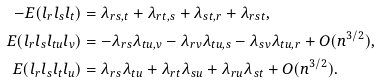Convert formula to latex. <formula><loc_0><loc_0><loc_500><loc_500>- E ( l _ { r } l _ { s } l _ { t } ) & = \lambda _ { r s , t } + \lambda _ { r t , s } + \lambda _ { s t , r } + \lambda _ { r s t } , \\ E ( l _ { r } l _ { s } l _ { t u } l _ { v } ) & = - \lambda _ { r s } \lambda _ { t u , v } - \lambda _ { r v } \lambda _ { t u , s } - \lambda _ { s v } \lambda _ { t u , r } + O ( n ^ { 3 / 2 } ) , \\ E ( l _ { r } l _ { s } l _ { t } l _ { u } ) & = \lambda _ { r s } \lambda _ { t u } + \lambda _ { r t } \lambda _ { s u } + \lambda _ { r u } \lambda _ { s t } + O ( n ^ { 3 / 2 } ) .</formula> 